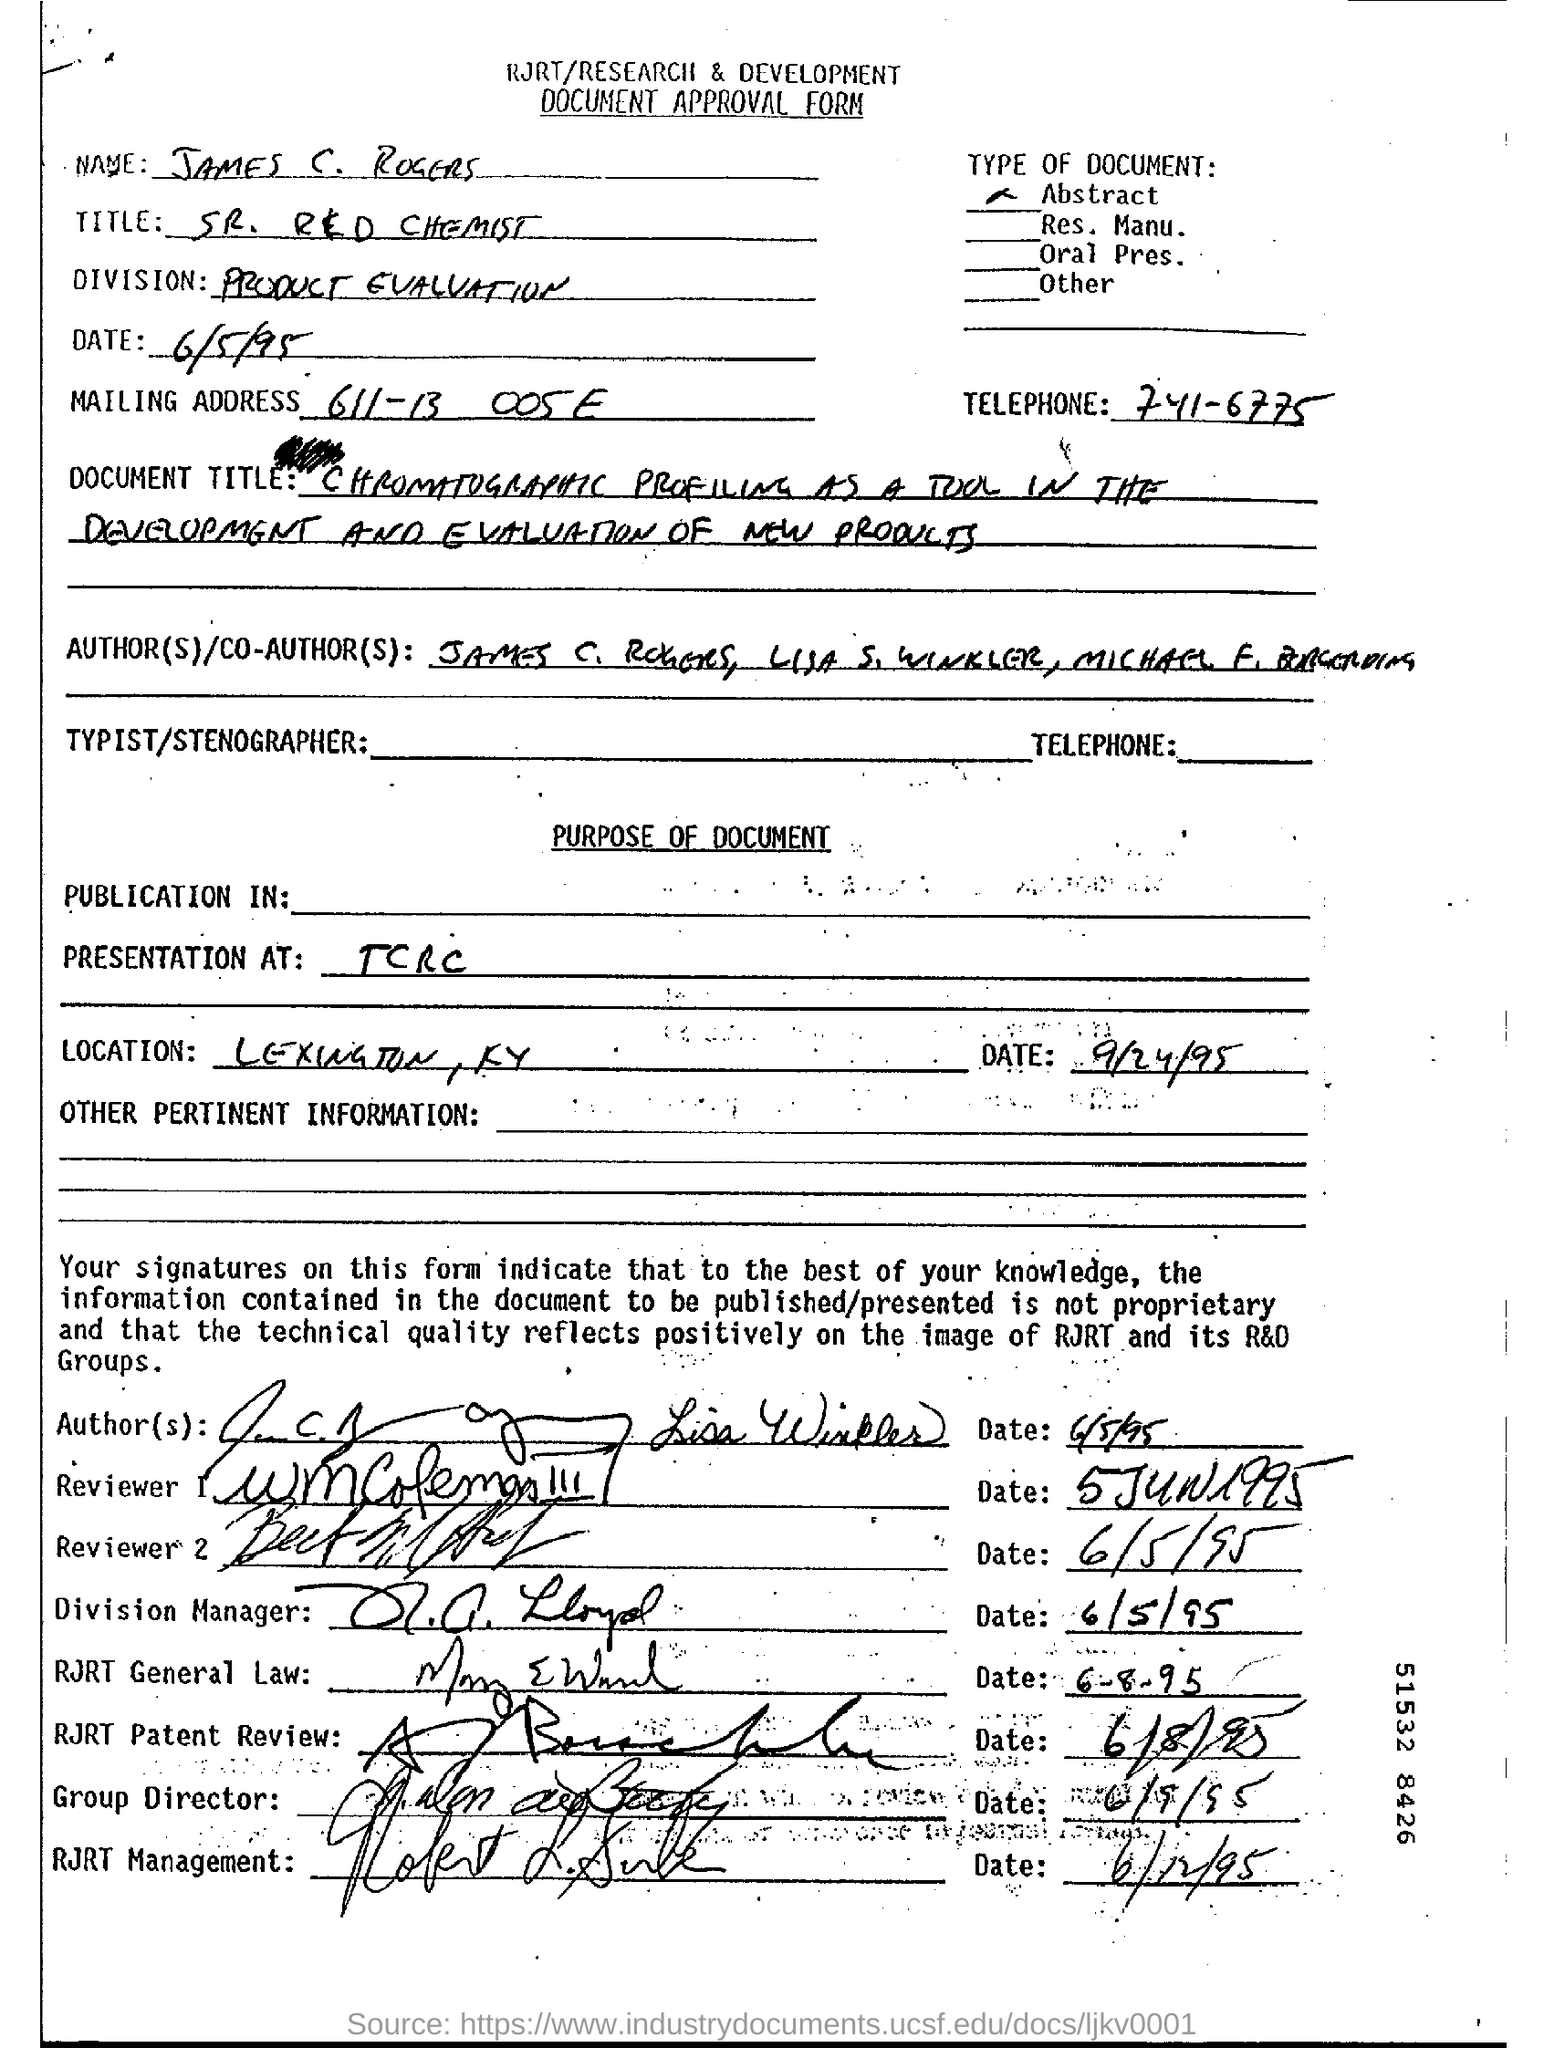Specify some key components in this picture. The division mentioned in the form is PRODUCT EVALUATION. The name of the person mentioned in the document is James C. Rogers. 